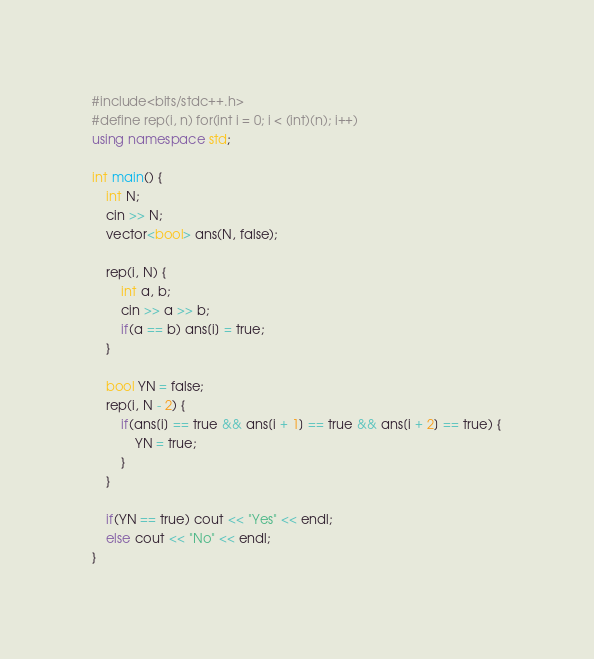<code> <loc_0><loc_0><loc_500><loc_500><_C++_>#include<bits/stdc++.h>
#define rep(i, n) for(int i = 0; i < (int)(n); i++)
using namespace std;

int main() {
    int N;
    cin >> N;
    vector<bool> ans(N, false);

    rep(i, N) {
        int a, b;
        cin >> a >> b;
        if(a == b) ans[i] = true;
    }
    
    bool YN = false;
    rep(i, N - 2) {
        if(ans[i] == true && ans[i + 1] == true && ans[i + 2] == true) {
            YN = true;
        }
    }

    if(YN == true) cout << "Yes" << endl;
    else cout << "No" << endl;
}</code> 